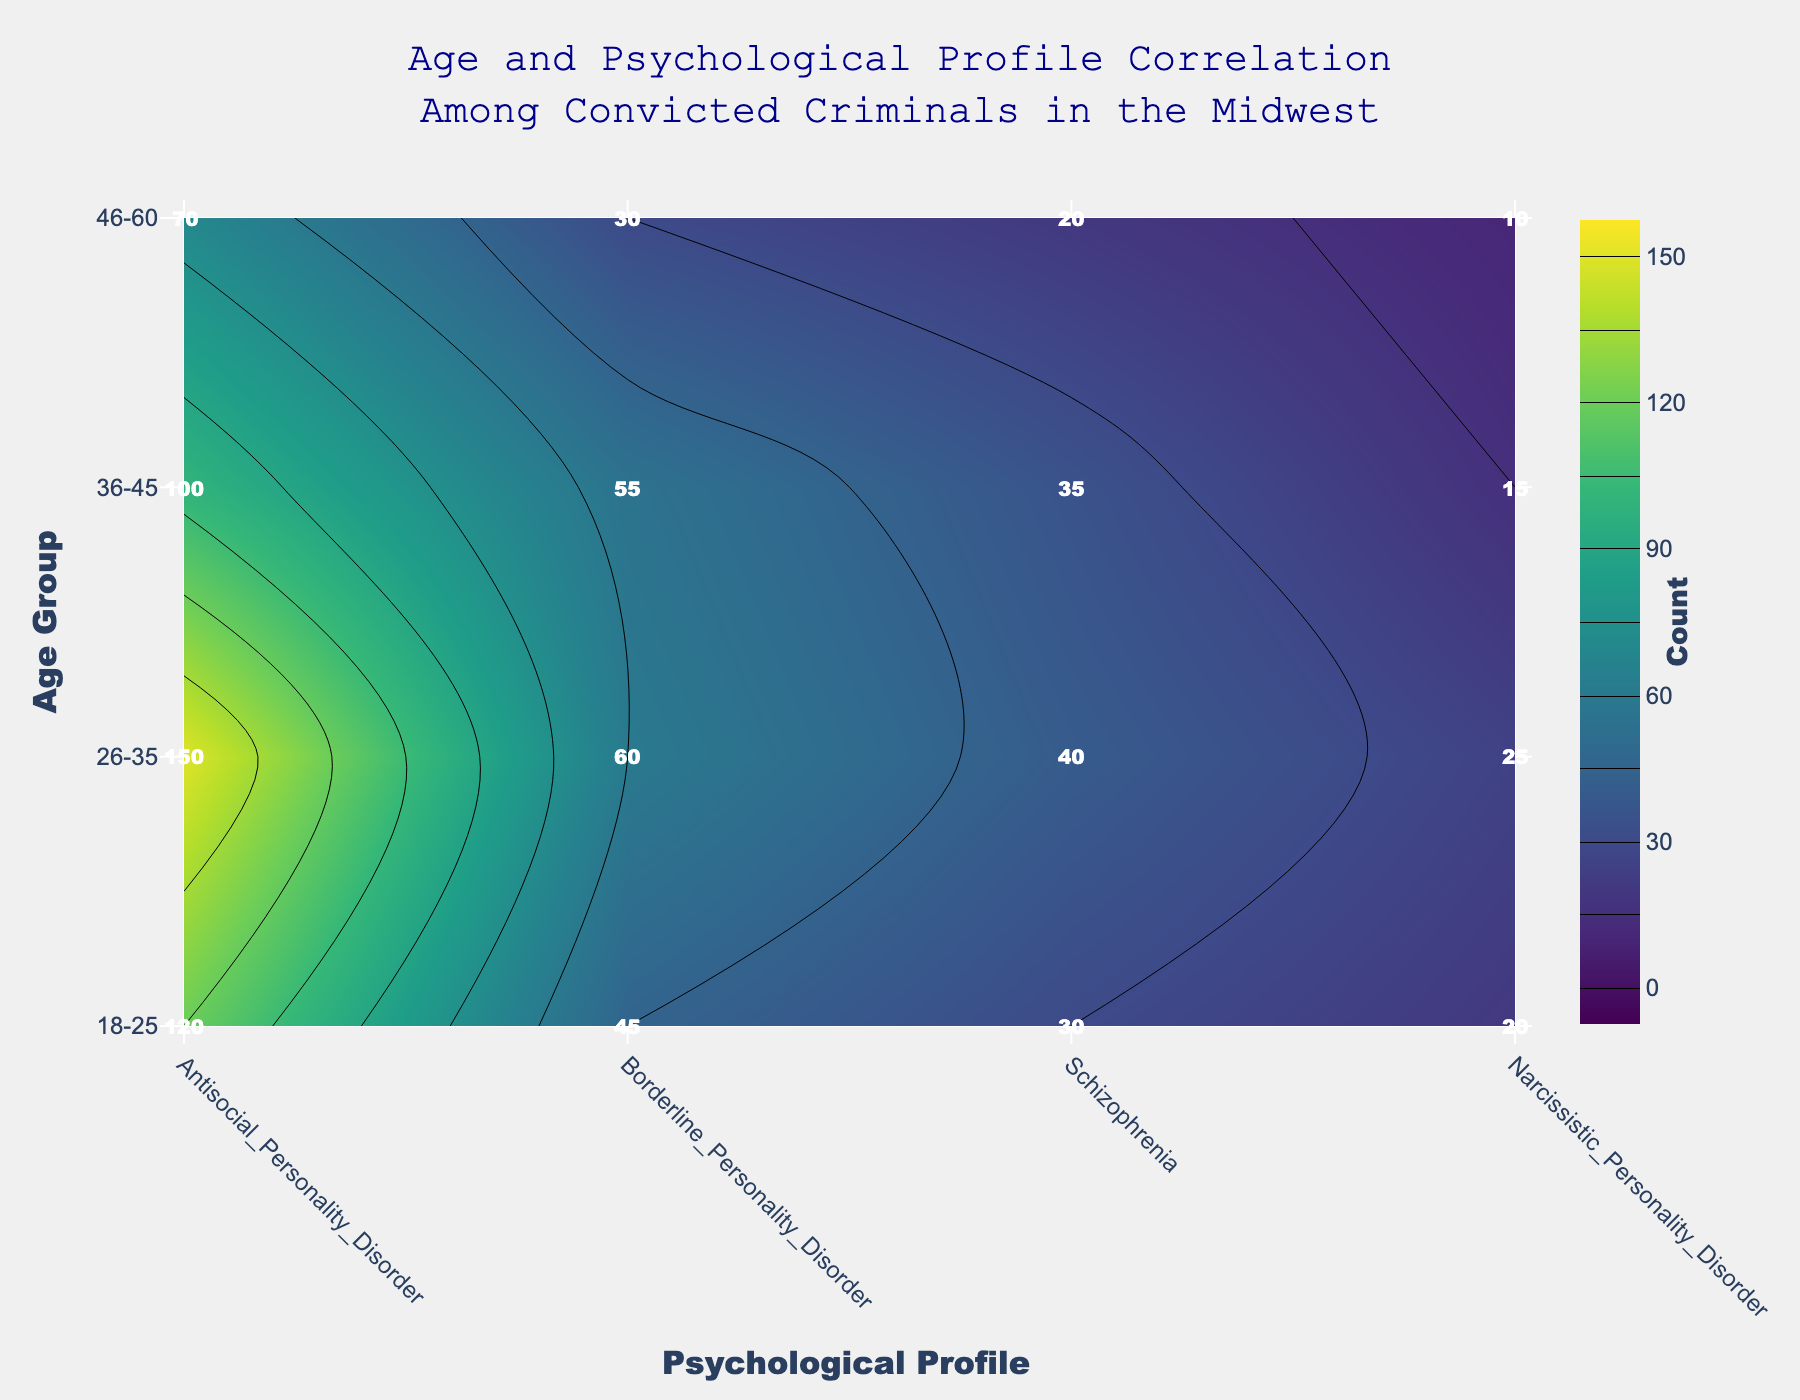What is the title of the figure? The title is located at the top center of the figure and is clearly displayed.
Answer: Age and Psychological Profile Correlation Among Convicted Criminals in the Midwest Which psychological profile has the highest count for the age group 26-35? Locate the highest contour level within the age group 26-35. The highest value appears at the intersection of the 26-35 age group and the Antisocial Personality Disorder profile.
Answer: Antisocial_Personality_Disorder How does the count of convicted criminals with Borderline Personality Disorder in the 36-45 age group compare to those in the 46-60 age group? Locate the counts for Borderline Personality Disorder in the 36-45 and 46-60 age groups. Compare these counts directly. The count is 55 for 36-45 and 30 for 46-60.
Answer: Greater in 36-45 What is the total count of convicted criminals aged 18-25 across all psychological profiles? Sum the counts for all psychological profiles in the 18-25 age group. The counts are 120, 45, 30, and 20 respectively. 120 + 45 + 30 + 20 = 215.
Answer: 215 Which age group has the fewest convicted criminals with Schizophrenia? Locate the counts for Schizophrenia across all age groups and identify the smallest value. The counts are 30, 40, 35, and 20 respectively. The smallest count is 20 in the 46-60 age group.
Answer: 46-60 In which psychological profile do the counts decrease continuously with age? Examine the counts for each profile across the four age groups (18-25, 26-35, 36-45, 46-60) and identify a profile where the counts decrease at each step. Narcissistic Personality Disorder is the profile where counts are 20, 25, 15, and 10 respectively, showing a decrease.
Answer: Narcissistic_Personality_Disorder What is the difference in count between Antisocial Personality Disorder and Schizophrenia for the age group 18-25? Subtract the count of Schizophrenia (30) from the count of Antisocial Personality Disorder (120) within the 18-25 age group. The difference is 120 - 30 = 90.
Answer: 90 Which psychological profile has the most uniform distribution across all age groups? Identify the psychological profile where the counts are most similar across all age groups. Borderline Personality Disorder has counts of 45, 60, 55, and 30 respectively, which show comparatively less variation.
Answer: Borderline_Personality_Disorder What is the average count of convicted criminals with Antisocial Personality Disorder across all age groups? Sum the counts for Antisocial Personality Disorder across all age groups and divide by the number of age groups. The counts are 120, 150, 100, and 70. Sum = 120 + 150 + 100 + 70 = 440. Average = 440 / 4 = 110.
Answer: 110 What is the highest count observed in the figure? Locate the highest value among all the contour levels within the entire plot. The maximum count observed is 150.
Answer: 150 